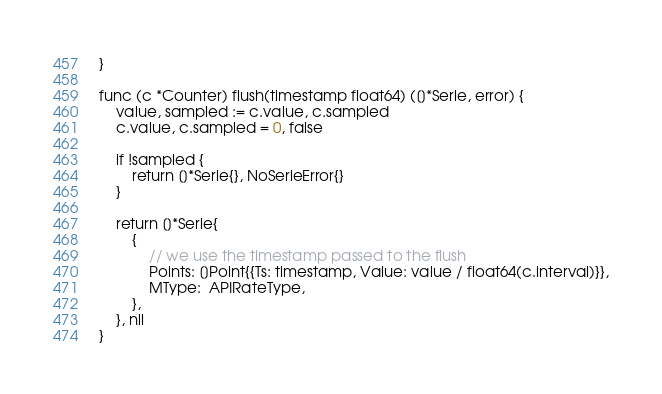<code> <loc_0><loc_0><loc_500><loc_500><_Go_>}

func (c *Counter) flush(timestamp float64) ([]*Serie, error) {
	value, sampled := c.value, c.sampled
	c.value, c.sampled = 0, false

	if !sampled {
		return []*Serie{}, NoSerieError{}
	}

	return []*Serie{
		{
			// we use the timestamp passed to the flush
			Points: []Point{{Ts: timestamp, Value: value / float64(c.interval)}},
			MType:  APIRateType,
		},
	}, nil
}
</code> 